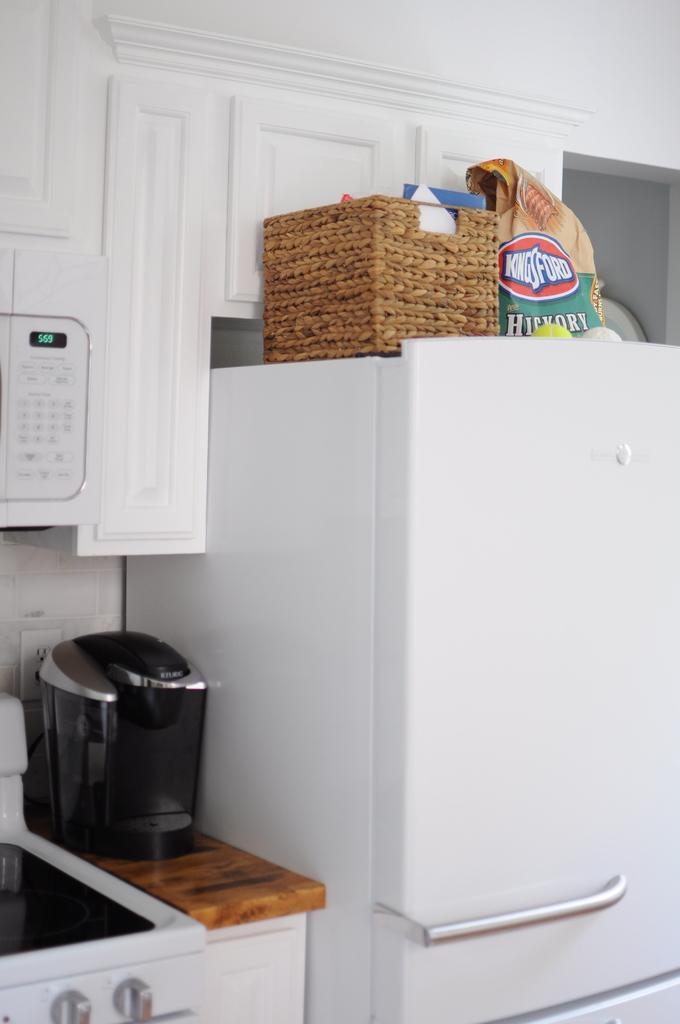<image>
Present a compact description of the photo's key features. A kitchen with appliances and a bag of KingsFord charcoal on the refrigerator. 